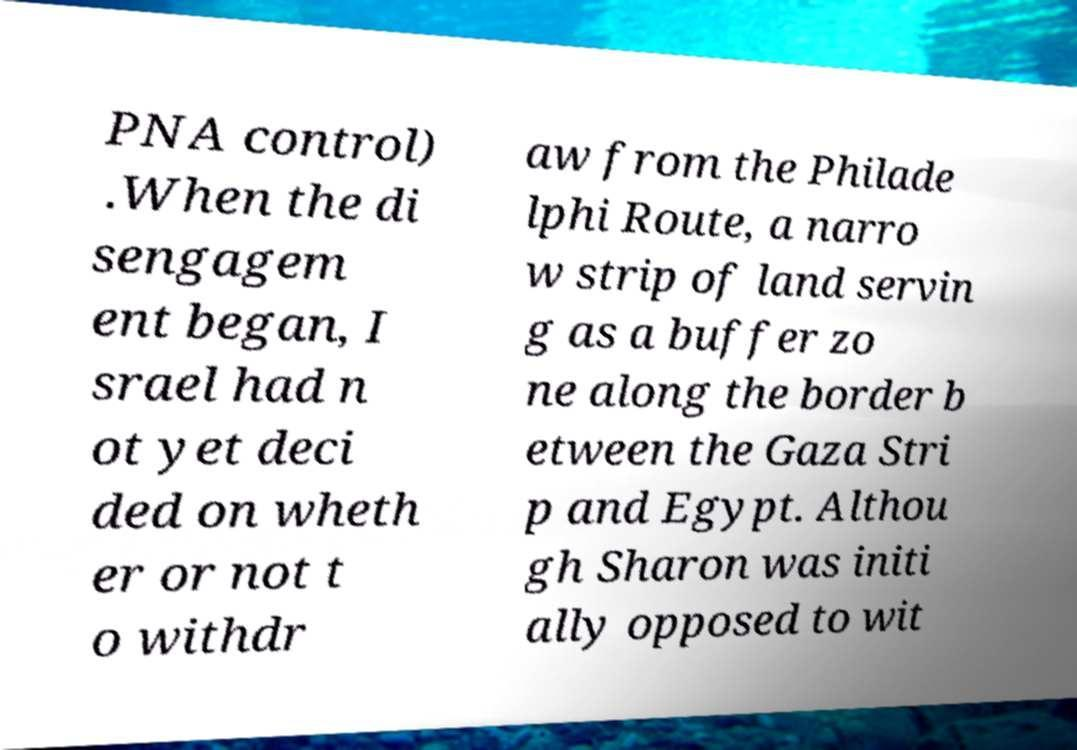Please read and relay the text visible in this image. What does it say? PNA control) .When the di sengagem ent began, I srael had n ot yet deci ded on wheth er or not t o withdr aw from the Philade lphi Route, a narro w strip of land servin g as a buffer zo ne along the border b etween the Gaza Stri p and Egypt. Althou gh Sharon was initi ally opposed to wit 